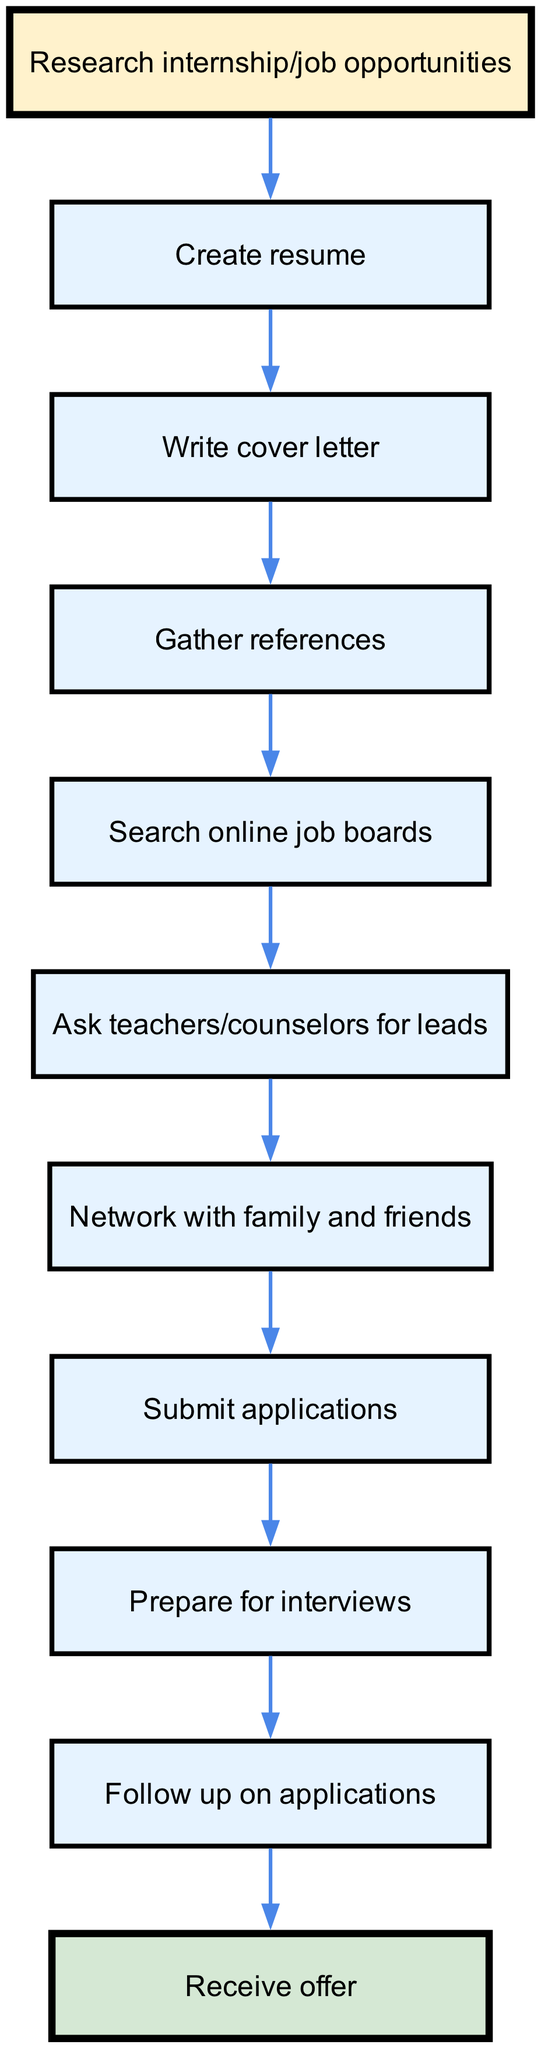What is the starting node in the diagram? The starting node is defined in the data as "Research internship/job opportunities." This is identified as the first step in the process before any other actions are taken.
Answer: Research internship/job opportunities How many nodes are present in the diagram? The nodes in the data include the start node and the following additional nodes. Counting all nodes listed reveals a total of 10 distinct nodes: 1 starting node and 9 subsequent steps.
Answer: 10 Which two nodes are connected directly before "Submit applications"? In the flow chart, the edge from "Network with family and friends" leads directly into "Submit applications," meaning these two nodes are linked in sequence.
Answer: Network with family and friends, Submit applications What comes immediately after "Prepare for interviews"? Following the flow in the diagram, the step that directly follows "Prepare for interviews" is "Follow up on applications." This is the next action after interview preparation.
Answer: Follow up on applications How many edges are in the diagram? Each edge connects one node to the next, and by counting the connections provided in the edges list, we find a total of 9 edges.
Answer: 9 Which node precedes "Gather references"? The node that comes directly before "Gather references" is "Write cover letter," as indicated by the flow connecting these two steps.
Answer: Write cover letter What is the last node in the process? The diagram indicates that "Receive offer" is the final step in the application process, concluding the workflow defined within the chart.
Answer: Receive offer What two actions must be taken before submitting applications? According to the flow, the actions "Network with family and friends" and "Gather references" must be completed before reaching the "Submit applications" node, as these steps directly lead into it.
Answer: Network with family and friends, Gather references Which node is highlighted to indicate the start of the process? The node marked with a specific color for emphasis on starting the process is "Research internship/job opportunities," distinguishing it from other nodes.
Answer: Research internship/job opportunities 